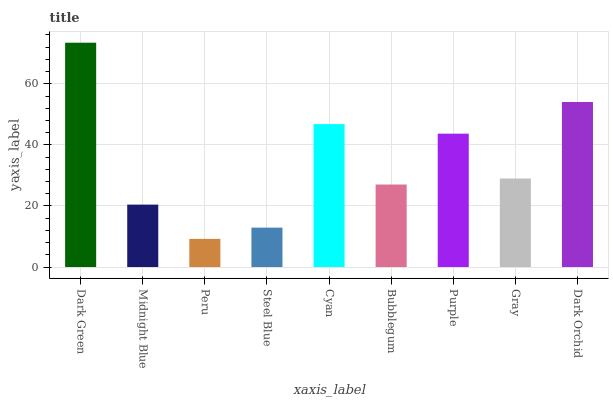Is Peru the minimum?
Answer yes or no. Yes. Is Dark Green the maximum?
Answer yes or no. Yes. Is Midnight Blue the minimum?
Answer yes or no. No. Is Midnight Blue the maximum?
Answer yes or no. No. Is Dark Green greater than Midnight Blue?
Answer yes or no. Yes. Is Midnight Blue less than Dark Green?
Answer yes or no. Yes. Is Midnight Blue greater than Dark Green?
Answer yes or no. No. Is Dark Green less than Midnight Blue?
Answer yes or no. No. Is Gray the high median?
Answer yes or no. Yes. Is Gray the low median?
Answer yes or no. Yes. Is Bubblegum the high median?
Answer yes or no. No. Is Bubblegum the low median?
Answer yes or no. No. 